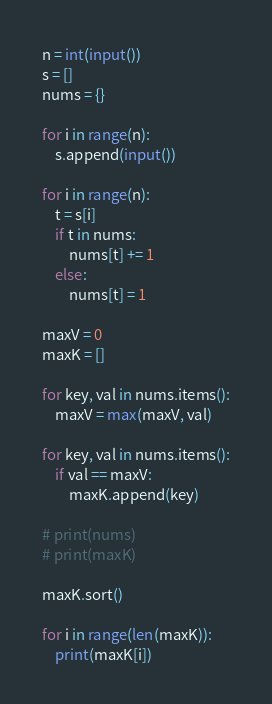<code> <loc_0><loc_0><loc_500><loc_500><_Python_>n = int(input())
s = []
nums = {}

for i in range(n):
    s.append(input())

for i in range(n):
    t = s[i]
    if t in nums:
        nums[t] += 1
    else:
        nums[t] = 1

maxV = 0
maxK = []

for key, val in nums.items():
    maxV = max(maxV, val)

for key, val in nums.items():
    if val == maxV:
        maxK.append(key)

# print(nums)
# print(maxK)

maxK.sort()

for i in range(len(maxK)):
    print(maxK[i])
</code> 